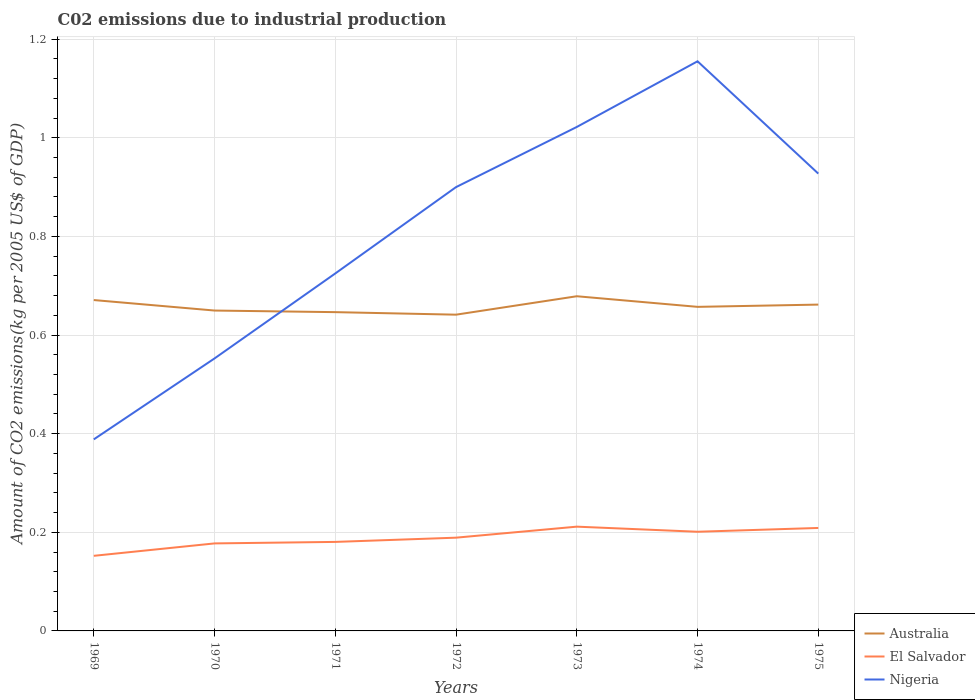Is the number of lines equal to the number of legend labels?
Your response must be concise. Yes. Across all years, what is the maximum amount of CO2 emitted due to industrial production in Australia?
Keep it short and to the point. 0.64. In which year was the amount of CO2 emitted due to industrial production in Nigeria maximum?
Provide a short and direct response. 1969. What is the total amount of CO2 emitted due to industrial production in Australia in the graph?
Provide a succinct answer. -0.01. What is the difference between the highest and the second highest amount of CO2 emitted due to industrial production in Australia?
Offer a terse response. 0.04. How many lines are there?
Keep it short and to the point. 3. How many years are there in the graph?
Provide a succinct answer. 7. What is the difference between two consecutive major ticks on the Y-axis?
Make the answer very short. 0.2. Are the values on the major ticks of Y-axis written in scientific E-notation?
Ensure brevity in your answer.  No. Does the graph contain any zero values?
Give a very brief answer. No. Where does the legend appear in the graph?
Make the answer very short. Bottom right. How many legend labels are there?
Your response must be concise. 3. What is the title of the graph?
Offer a terse response. C02 emissions due to industrial production. What is the label or title of the X-axis?
Keep it short and to the point. Years. What is the label or title of the Y-axis?
Your answer should be compact. Amount of CO2 emissions(kg per 2005 US$ of GDP). What is the Amount of CO2 emissions(kg per 2005 US$ of GDP) of Australia in 1969?
Make the answer very short. 0.67. What is the Amount of CO2 emissions(kg per 2005 US$ of GDP) of El Salvador in 1969?
Keep it short and to the point. 0.15. What is the Amount of CO2 emissions(kg per 2005 US$ of GDP) of Nigeria in 1969?
Provide a succinct answer. 0.39. What is the Amount of CO2 emissions(kg per 2005 US$ of GDP) in Australia in 1970?
Provide a short and direct response. 0.65. What is the Amount of CO2 emissions(kg per 2005 US$ of GDP) of El Salvador in 1970?
Provide a short and direct response. 0.18. What is the Amount of CO2 emissions(kg per 2005 US$ of GDP) of Nigeria in 1970?
Offer a very short reply. 0.55. What is the Amount of CO2 emissions(kg per 2005 US$ of GDP) of Australia in 1971?
Provide a short and direct response. 0.65. What is the Amount of CO2 emissions(kg per 2005 US$ of GDP) of El Salvador in 1971?
Provide a succinct answer. 0.18. What is the Amount of CO2 emissions(kg per 2005 US$ of GDP) in Nigeria in 1971?
Provide a succinct answer. 0.72. What is the Amount of CO2 emissions(kg per 2005 US$ of GDP) in Australia in 1972?
Your answer should be compact. 0.64. What is the Amount of CO2 emissions(kg per 2005 US$ of GDP) in El Salvador in 1972?
Your answer should be very brief. 0.19. What is the Amount of CO2 emissions(kg per 2005 US$ of GDP) of Nigeria in 1972?
Keep it short and to the point. 0.9. What is the Amount of CO2 emissions(kg per 2005 US$ of GDP) of Australia in 1973?
Your response must be concise. 0.68. What is the Amount of CO2 emissions(kg per 2005 US$ of GDP) of El Salvador in 1973?
Your answer should be very brief. 0.21. What is the Amount of CO2 emissions(kg per 2005 US$ of GDP) in Nigeria in 1973?
Make the answer very short. 1.02. What is the Amount of CO2 emissions(kg per 2005 US$ of GDP) in Australia in 1974?
Keep it short and to the point. 0.66. What is the Amount of CO2 emissions(kg per 2005 US$ of GDP) in El Salvador in 1974?
Your answer should be very brief. 0.2. What is the Amount of CO2 emissions(kg per 2005 US$ of GDP) of Nigeria in 1974?
Provide a succinct answer. 1.16. What is the Amount of CO2 emissions(kg per 2005 US$ of GDP) in Australia in 1975?
Make the answer very short. 0.66. What is the Amount of CO2 emissions(kg per 2005 US$ of GDP) in El Salvador in 1975?
Give a very brief answer. 0.21. What is the Amount of CO2 emissions(kg per 2005 US$ of GDP) of Nigeria in 1975?
Your answer should be very brief. 0.93. Across all years, what is the maximum Amount of CO2 emissions(kg per 2005 US$ of GDP) in Australia?
Offer a terse response. 0.68. Across all years, what is the maximum Amount of CO2 emissions(kg per 2005 US$ of GDP) of El Salvador?
Your response must be concise. 0.21. Across all years, what is the maximum Amount of CO2 emissions(kg per 2005 US$ of GDP) in Nigeria?
Your answer should be compact. 1.16. Across all years, what is the minimum Amount of CO2 emissions(kg per 2005 US$ of GDP) in Australia?
Your answer should be very brief. 0.64. Across all years, what is the minimum Amount of CO2 emissions(kg per 2005 US$ of GDP) of El Salvador?
Make the answer very short. 0.15. Across all years, what is the minimum Amount of CO2 emissions(kg per 2005 US$ of GDP) in Nigeria?
Keep it short and to the point. 0.39. What is the total Amount of CO2 emissions(kg per 2005 US$ of GDP) of Australia in the graph?
Make the answer very short. 4.61. What is the total Amount of CO2 emissions(kg per 2005 US$ of GDP) in El Salvador in the graph?
Keep it short and to the point. 1.32. What is the total Amount of CO2 emissions(kg per 2005 US$ of GDP) in Nigeria in the graph?
Keep it short and to the point. 5.67. What is the difference between the Amount of CO2 emissions(kg per 2005 US$ of GDP) in Australia in 1969 and that in 1970?
Provide a short and direct response. 0.02. What is the difference between the Amount of CO2 emissions(kg per 2005 US$ of GDP) in El Salvador in 1969 and that in 1970?
Make the answer very short. -0.03. What is the difference between the Amount of CO2 emissions(kg per 2005 US$ of GDP) of Nigeria in 1969 and that in 1970?
Provide a succinct answer. -0.16. What is the difference between the Amount of CO2 emissions(kg per 2005 US$ of GDP) of Australia in 1969 and that in 1971?
Ensure brevity in your answer.  0.02. What is the difference between the Amount of CO2 emissions(kg per 2005 US$ of GDP) in El Salvador in 1969 and that in 1971?
Ensure brevity in your answer.  -0.03. What is the difference between the Amount of CO2 emissions(kg per 2005 US$ of GDP) in Nigeria in 1969 and that in 1971?
Offer a very short reply. -0.34. What is the difference between the Amount of CO2 emissions(kg per 2005 US$ of GDP) in Australia in 1969 and that in 1972?
Make the answer very short. 0.03. What is the difference between the Amount of CO2 emissions(kg per 2005 US$ of GDP) of El Salvador in 1969 and that in 1972?
Your answer should be very brief. -0.04. What is the difference between the Amount of CO2 emissions(kg per 2005 US$ of GDP) of Nigeria in 1969 and that in 1972?
Ensure brevity in your answer.  -0.51. What is the difference between the Amount of CO2 emissions(kg per 2005 US$ of GDP) in Australia in 1969 and that in 1973?
Offer a very short reply. -0.01. What is the difference between the Amount of CO2 emissions(kg per 2005 US$ of GDP) in El Salvador in 1969 and that in 1973?
Offer a terse response. -0.06. What is the difference between the Amount of CO2 emissions(kg per 2005 US$ of GDP) in Nigeria in 1969 and that in 1973?
Keep it short and to the point. -0.63. What is the difference between the Amount of CO2 emissions(kg per 2005 US$ of GDP) of Australia in 1969 and that in 1974?
Your answer should be compact. 0.01. What is the difference between the Amount of CO2 emissions(kg per 2005 US$ of GDP) of El Salvador in 1969 and that in 1974?
Provide a succinct answer. -0.05. What is the difference between the Amount of CO2 emissions(kg per 2005 US$ of GDP) of Nigeria in 1969 and that in 1974?
Your answer should be very brief. -0.77. What is the difference between the Amount of CO2 emissions(kg per 2005 US$ of GDP) of Australia in 1969 and that in 1975?
Offer a very short reply. 0.01. What is the difference between the Amount of CO2 emissions(kg per 2005 US$ of GDP) of El Salvador in 1969 and that in 1975?
Offer a very short reply. -0.06. What is the difference between the Amount of CO2 emissions(kg per 2005 US$ of GDP) of Nigeria in 1969 and that in 1975?
Keep it short and to the point. -0.54. What is the difference between the Amount of CO2 emissions(kg per 2005 US$ of GDP) of Australia in 1970 and that in 1971?
Your answer should be very brief. 0. What is the difference between the Amount of CO2 emissions(kg per 2005 US$ of GDP) in El Salvador in 1970 and that in 1971?
Give a very brief answer. -0. What is the difference between the Amount of CO2 emissions(kg per 2005 US$ of GDP) in Nigeria in 1970 and that in 1971?
Ensure brevity in your answer.  -0.17. What is the difference between the Amount of CO2 emissions(kg per 2005 US$ of GDP) in Australia in 1970 and that in 1972?
Provide a short and direct response. 0.01. What is the difference between the Amount of CO2 emissions(kg per 2005 US$ of GDP) in El Salvador in 1970 and that in 1972?
Offer a terse response. -0.01. What is the difference between the Amount of CO2 emissions(kg per 2005 US$ of GDP) of Nigeria in 1970 and that in 1972?
Make the answer very short. -0.35. What is the difference between the Amount of CO2 emissions(kg per 2005 US$ of GDP) in Australia in 1970 and that in 1973?
Provide a succinct answer. -0.03. What is the difference between the Amount of CO2 emissions(kg per 2005 US$ of GDP) of El Salvador in 1970 and that in 1973?
Offer a very short reply. -0.03. What is the difference between the Amount of CO2 emissions(kg per 2005 US$ of GDP) of Nigeria in 1970 and that in 1973?
Offer a terse response. -0.47. What is the difference between the Amount of CO2 emissions(kg per 2005 US$ of GDP) in Australia in 1970 and that in 1974?
Your response must be concise. -0.01. What is the difference between the Amount of CO2 emissions(kg per 2005 US$ of GDP) of El Salvador in 1970 and that in 1974?
Your answer should be compact. -0.02. What is the difference between the Amount of CO2 emissions(kg per 2005 US$ of GDP) in Nigeria in 1970 and that in 1974?
Offer a very short reply. -0.6. What is the difference between the Amount of CO2 emissions(kg per 2005 US$ of GDP) of Australia in 1970 and that in 1975?
Ensure brevity in your answer.  -0.01. What is the difference between the Amount of CO2 emissions(kg per 2005 US$ of GDP) in El Salvador in 1970 and that in 1975?
Your response must be concise. -0.03. What is the difference between the Amount of CO2 emissions(kg per 2005 US$ of GDP) of Nigeria in 1970 and that in 1975?
Ensure brevity in your answer.  -0.37. What is the difference between the Amount of CO2 emissions(kg per 2005 US$ of GDP) in Australia in 1971 and that in 1972?
Your answer should be very brief. 0.01. What is the difference between the Amount of CO2 emissions(kg per 2005 US$ of GDP) in El Salvador in 1971 and that in 1972?
Make the answer very short. -0.01. What is the difference between the Amount of CO2 emissions(kg per 2005 US$ of GDP) of Nigeria in 1971 and that in 1972?
Offer a terse response. -0.18. What is the difference between the Amount of CO2 emissions(kg per 2005 US$ of GDP) in Australia in 1971 and that in 1973?
Offer a very short reply. -0.03. What is the difference between the Amount of CO2 emissions(kg per 2005 US$ of GDP) in El Salvador in 1971 and that in 1973?
Make the answer very short. -0.03. What is the difference between the Amount of CO2 emissions(kg per 2005 US$ of GDP) of Nigeria in 1971 and that in 1973?
Offer a very short reply. -0.3. What is the difference between the Amount of CO2 emissions(kg per 2005 US$ of GDP) in Australia in 1971 and that in 1974?
Offer a very short reply. -0.01. What is the difference between the Amount of CO2 emissions(kg per 2005 US$ of GDP) of El Salvador in 1971 and that in 1974?
Ensure brevity in your answer.  -0.02. What is the difference between the Amount of CO2 emissions(kg per 2005 US$ of GDP) in Nigeria in 1971 and that in 1974?
Provide a succinct answer. -0.43. What is the difference between the Amount of CO2 emissions(kg per 2005 US$ of GDP) in Australia in 1971 and that in 1975?
Provide a succinct answer. -0.02. What is the difference between the Amount of CO2 emissions(kg per 2005 US$ of GDP) of El Salvador in 1971 and that in 1975?
Your response must be concise. -0.03. What is the difference between the Amount of CO2 emissions(kg per 2005 US$ of GDP) in Nigeria in 1971 and that in 1975?
Offer a very short reply. -0.2. What is the difference between the Amount of CO2 emissions(kg per 2005 US$ of GDP) of Australia in 1972 and that in 1973?
Provide a succinct answer. -0.04. What is the difference between the Amount of CO2 emissions(kg per 2005 US$ of GDP) of El Salvador in 1972 and that in 1973?
Give a very brief answer. -0.02. What is the difference between the Amount of CO2 emissions(kg per 2005 US$ of GDP) in Nigeria in 1972 and that in 1973?
Offer a terse response. -0.12. What is the difference between the Amount of CO2 emissions(kg per 2005 US$ of GDP) in Australia in 1972 and that in 1974?
Your answer should be compact. -0.02. What is the difference between the Amount of CO2 emissions(kg per 2005 US$ of GDP) in El Salvador in 1972 and that in 1974?
Give a very brief answer. -0.01. What is the difference between the Amount of CO2 emissions(kg per 2005 US$ of GDP) in Nigeria in 1972 and that in 1974?
Your answer should be compact. -0.26. What is the difference between the Amount of CO2 emissions(kg per 2005 US$ of GDP) of Australia in 1972 and that in 1975?
Your answer should be very brief. -0.02. What is the difference between the Amount of CO2 emissions(kg per 2005 US$ of GDP) of El Salvador in 1972 and that in 1975?
Offer a terse response. -0.02. What is the difference between the Amount of CO2 emissions(kg per 2005 US$ of GDP) in Nigeria in 1972 and that in 1975?
Provide a succinct answer. -0.03. What is the difference between the Amount of CO2 emissions(kg per 2005 US$ of GDP) in Australia in 1973 and that in 1974?
Keep it short and to the point. 0.02. What is the difference between the Amount of CO2 emissions(kg per 2005 US$ of GDP) in El Salvador in 1973 and that in 1974?
Offer a very short reply. 0.01. What is the difference between the Amount of CO2 emissions(kg per 2005 US$ of GDP) of Nigeria in 1973 and that in 1974?
Offer a very short reply. -0.13. What is the difference between the Amount of CO2 emissions(kg per 2005 US$ of GDP) in Australia in 1973 and that in 1975?
Provide a succinct answer. 0.02. What is the difference between the Amount of CO2 emissions(kg per 2005 US$ of GDP) in El Salvador in 1973 and that in 1975?
Provide a short and direct response. 0. What is the difference between the Amount of CO2 emissions(kg per 2005 US$ of GDP) in Nigeria in 1973 and that in 1975?
Your answer should be compact. 0.09. What is the difference between the Amount of CO2 emissions(kg per 2005 US$ of GDP) in Australia in 1974 and that in 1975?
Your answer should be very brief. -0. What is the difference between the Amount of CO2 emissions(kg per 2005 US$ of GDP) in El Salvador in 1974 and that in 1975?
Give a very brief answer. -0.01. What is the difference between the Amount of CO2 emissions(kg per 2005 US$ of GDP) in Nigeria in 1974 and that in 1975?
Offer a terse response. 0.23. What is the difference between the Amount of CO2 emissions(kg per 2005 US$ of GDP) of Australia in 1969 and the Amount of CO2 emissions(kg per 2005 US$ of GDP) of El Salvador in 1970?
Give a very brief answer. 0.49. What is the difference between the Amount of CO2 emissions(kg per 2005 US$ of GDP) of Australia in 1969 and the Amount of CO2 emissions(kg per 2005 US$ of GDP) of Nigeria in 1970?
Offer a terse response. 0.12. What is the difference between the Amount of CO2 emissions(kg per 2005 US$ of GDP) in El Salvador in 1969 and the Amount of CO2 emissions(kg per 2005 US$ of GDP) in Nigeria in 1970?
Give a very brief answer. -0.4. What is the difference between the Amount of CO2 emissions(kg per 2005 US$ of GDP) of Australia in 1969 and the Amount of CO2 emissions(kg per 2005 US$ of GDP) of El Salvador in 1971?
Keep it short and to the point. 0.49. What is the difference between the Amount of CO2 emissions(kg per 2005 US$ of GDP) in Australia in 1969 and the Amount of CO2 emissions(kg per 2005 US$ of GDP) in Nigeria in 1971?
Your answer should be very brief. -0.05. What is the difference between the Amount of CO2 emissions(kg per 2005 US$ of GDP) of El Salvador in 1969 and the Amount of CO2 emissions(kg per 2005 US$ of GDP) of Nigeria in 1971?
Give a very brief answer. -0.57. What is the difference between the Amount of CO2 emissions(kg per 2005 US$ of GDP) in Australia in 1969 and the Amount of CO2 emissions(kg per 2005 US$ of GDP) in El Salvador in 1972?
Provide a succinct answer. 0.48. What is the difference between the Amount of CO2 emissions(kg per 2005 US$ of GDP) in Australia in 1969 and the Amount of CO2 emissions(kg per 2005 US$ of GDP) in Nigeria in 1972?
Your response must be concise. -0.23. What is the difference between the Amount of CO2 emissions(kg per 2005 US$ of GDP) of El Salvador in 1969 and the Amount of CO2 emissions(kg per 2005 US$ of GDP) of Nigeria in 1972?
Offer a terse response. -0.75. What is the difference between the Amount of CO2 emissions(kg per 2005 US$ of GDP) of Australia in 1969 and the Amount of CO2 emissions(kg per 2005 US$ of GDP) of El Salvador in 1973?
Offer a terse response. 0.46. What is the difference between the Amount of CO2 emissions(kg per 2005 US$ of GDP) in Australia in 1969 and the Amount of CO2 emissions(kg per 2005 US$ of GDP) in Nigeria in 1973?
Your answer should be very brief. -0.35. What is the difference between the Amount of CO2 emissions(kg per 2005 US$ of GDP) in El Salvador in 1969 and the Amount of CO2 emissions(kg per 2005 US$ of GDP) in Nigeria in 1973?
Ensure brevity in your answer.  -0.87. What is the difference between the Amount of CO2 emissions(kg per 2005 US$ of GDP) of Australia in 1969 and the Amount of CO2 emissions(kg per 2005 US$ of GDP) of El Salvador in 1974?
Offer a very short reply. 0.47. What is the difference between the Amount of CO2 emissions(kg per 2005 US$ of GDP) of Australia in 1969 and the Amount of CO2 emissions(kg per 2005 US$ of GDP) of Nigeria in 1974?
Your answer should be very brief. -0.48. What is the difference between the Amount of CO2 emissions(kg per 2005 US$ of GDP) of El Salvador in 1969 and the Amount of CO2 emissions(kg per 2005 US$ of GDP) of Nigeria in 1974?
Provide a short and direct response. -1. What is the difference between the Amount of CO2 emissions(kg per 2005 US$ of GDP) in Australia in 1969 and the Amount of CO2 emissions(kg per 2005 US$ of GDP) in El Salvador in 1975?
Keep it short and to the point. 0.46. What is the difference between the Amount of CO2 emissions(kg per 2005 US$ of GDP) of Australia in 1969 and the Amount of CO2 emissions(kg per 2005 US$ of GDP) of Nigeria in 1975?
Provide a short and direct response. -0.26. What is the difference between the Amount of CO2 emissions(kg per 2005 US$ of GDP) in El Salvador in 1969 and the Amount of CO2 emissions(kg per 2005 US$ of GDP) in Nigeria in 1975?
Provide a short and direct response. -0.78. What is the difference between the Amount of CO2 emissions(kg per 2005 US$ of GDP) in Australia in 1970 and the Amount of CO2 emissions(kg per 2005 US$ of GDP) in El Salvador in 1971?
Your answer should be very brief. 0.47. What is the difference between the Amount of CO2 emissions(kg per 2005 US$ of GDP) in Australia in 1970 and the Amount of CO2 emissions(kg per 2005 US$ of GDP) in Nigeria in 1971?
Your response must be concise. -0.08. What is the difference between the Amount of CO2 emissions(kg per 2005 US$ of GDP) of El Salvador in 1970 and the Amount of CO2 emissions(kg per 2005 US$ of GDP) of Nigeria in 1971?
Provide a succinct answer. -0.55. What is the difference between the Amount of CO2 emissions(kg per 2005 US$ of GDP) of Australia in 1970 and the Amount of CO2 emissions(kg per 2005 US$ of GDP) of El Salvador in 1972?
Your response must be concise. 0.46. What is the difference between the Amount of CO2 emissions(kg per 2005 US$ of GDP) of Australia in 1970 and the Amount of CO2 emissions(kg per 2005 US$ of GDP) of Nigeria in 1972?
Make the answer very short. -0.25. What is the difference between the Amount of CO2 emissions(kg per 2005 US$ of GDP) in El Salvador in 1970 and the Amount of CO2 emissions(kg per 2005 US$ of GDP) in Nigeria in 1972?
Make the answer very short. -0.72. What is the difference between the Amount of CO2 emissions(kg per 2005 US$ of GDP) of Australia in 1970 and the Amount of CO2 emissions(kg per 2005 US$ of GDP) of El Salvador in 1973?
Provide a short and direct response. 0.44. What is the difference between the Amount of CO2 emissions(kg per 2005 US$ of GDP) of Australia in 1970 and the Amount of CO2 emissions(kg per 2005 US$ of GDP) of Nigeria in 1973?
Your response must be concise. -0.37. What is the difference between the Amount of CO2 emissions(kg per 2005 US$ of GDP) of El Salvador in 1970 and the Amount of CO2 emissions(kg per 2005 US$ of GDP) of Nigeria in 1973?
Ensure brevity in your answer.  -0.84. What is the difference between the Amount of CO2 emissions(kg per 2005 US$ of GDP) of Australia in 1970 and the Amount of CO2 emissions(kg per 2005 US$ of GDP) of El Salvador in 1974?
Keep it short and to the point. 0.45. What is the difference between the Amount of CO2 emissions(kg per 2005 US$ of GDP) in Australia in 1970 and the Amount of CO2 emissions(kg per 2005 US$ of GDP) in Nigeria in 1974?
Give a very brief answer. -0.51. What is the difference between the Amount of CO2 emissions(kg per 2005 US$ of GDP) of El Salvador in 1970 and the Amount of CO2 emissions(kg per 2005 US$ of GDP) of Nigeria in 1974?
Offer a terse response. -0.98. What is the difference between the Amount of CO2 emissions(kg per 2005 US$ of GDP) of Australia in 1970 and the Amount of CO2 emissions(kg per 2005 US$ of GDP) of El Salvador in 1975?
Provide a short and direct response. 0.44. What is the difference between the Amount of CO2 emissions(kg per 2005 US$ of GDP) in Australia in 1970 and the Amount of CO2 emissions(kg per 2005 US$ of GDP) in Nigeria in 1975?
Give a very brief answer. -0.28. What is the difference between the Amount of CO2 emissions(kg per 2005 US$ of GDP) of El Salvador in 1970 and the Amount of CO2 emissions(kg per 2005 US$ of GDP) of Nigeria in 1975?
Your answer should be compact. -0.75. What is the difference between the Amount of CO2 emissions(kg per 2005 US$ of GDP) in Australia in 1971 and the Amount of CO2 emissions(kg per 2005 US$ of GDP) in El Salvador in 1972?
Offer a very short reply. 0.46. What is the difference between the Amount of CO2 emissions(kg per 2005 US$ of GDP) in Australia in 1971 and the Amount of CO2 emissions(kg per 2005 US$ of GDP) in Nigeria in 1972?
Provide a succinct answer. -0.25. What is the difference between the Amount of CO2 emissions(kg per 2005 US$ of GDP) of El Salvador in 1971 and the Amount of CO2 emissions(kg per 2005 US$ of GDP) of Nigeria in 1972?
Offer a terse response. -0.72. What is the difference between the Amount of CO2 emissions(kg per 2005 US$ of GDP) in Australia in 1971 and the Amount of CO2 emissions(kg per 2005 US$ of GDP) in El Salvador in 1973?
Provide a succinct answer. 0.43. What is the difference between the Amount of CO2 emissions(kg per 2005 US$ of GDP) of Australia in 1971 and the Amount of CO2 emissions(kg per 2005 US$ of GDP) of Nigeria in 1973?
Your answer should be compact. -0.38. What is the difference between the Amount of CO2 emissions(kg per 2005 US$ of GDP) in El Salvador in 1971 and the Amount of CO2 emissions(kg per 2005 US$ of GDP) in Nigeria in 1973?
Your answer should be compact. -0.84. What is the difference between the Amount of CO2 emissions(kg per 2005 US$ of GDP) in Australia in 1971 and the Amount of CO2 emissions(kg per 2005 US$ of GDP) in El Salvador in 1974?
Provide a succinct answer. 0.45. What is the difference between the Amount of CO2 emissions(kg per 2005 US$ of GDP) in Australia in 1971 and the Amount of CO2 emissions(kg per 2005 US$ of GDP) in Nigeria in 1974?
Keep it short and to the point. -0.51. What is the difference between the Amount of CO2 emissions(kg per 2005 US$ of GDP) in El Salvador in 1971 and the Amount of CO2 emissions(kg per 2005 US$ of GDP) in Nigeria in 1974?
Make the answer very short. -0.97. What is the difference between the Amount of CO2 emissions(kg per 2005 US$ of GDP) in Australia in 1971 and the Amount of CO2 emissions(kg per 2005 US$ of GDP) in El Salvador in 1975?
Keep it short and to the point. 0.44. What is the difference between the Amount of CO2 emissions(kg per 2005 US$ of GDP) in Australia in 1971 and the Amount of CO2 emissions(kg per 2005 US$ of GDP) in Nigeria in 1975?
Provide a short and direct response. -0.28. What is the difference between the Amount of CO2 emissions(kg per 2005 US$ of GDP) in El Salvador in 1971 and the Amount of CO2 emissions(kg per 2005 US$ of GDP) in Nigeria in 1975?
Ensure brevity in your answer.  -0.75. What is the difference between the Amount of CO2 emissions(kg per 2005 US$ of GDP) of Australia in 1972 and the Amount of CO2 emissions(kg per 2005 US$ of GDP) of El Salvador in 1973?
Keep it short and to the point. 0.43. What is the difference between the Amount of CO2 emissions(kg per 2005 US$ of GDP) of Australia in 1972 and the Amount of CO2 emissions(kg per 2005 US$ of GDP) of Nigeria in 1973?
Offer a very short reply. -0.38. What is the difference between the Amount of CO2 emissions(kg per 2005 US$ of GDP) of El Salvador in 1972 and the Amount of CO2 emissions(kg per 2005 US$ of GDP) of Nigeria in 1973?
Give a very brief answer. -0.83. What is the difference between the Amount of CO2 emissions(kg per 2005 US$ of GDP) in Australia in 1972 and the Amount of CO2 emissions(kg per 2005 US$ of GDP) in El Salvador in 1974?
Offer a very short reply. 0.44. What is the difference between the Amount of CO2 emissions(kg per 2005 US$ of GDP) of Australia in 1972 and the Amount of CO2 emissions(kg per 2005 US$ of GDP) of Nigeria in 1974?
Ensure brevity in your answer.  -0.51. What is the difference between the Amount of CO2 emissions(kg per 2005 US$ of GDP) of El Salvador in 1972 and the Amount of CO2 emissions(kg per 2005 US$ of GDP) of Nigeria in 1974?
Offer a terse response. -0.97. What is the difference between the Amount of CO2 emissions(kg per 2005 US$ of GDP) of Australia in 1972 and the Amount of CO2 emissions(kg per 2005 US$ of GDP) of El Salvador in 1975?
Your answer should be very brief. 0.43. What is the difference between the Amount of CO2 emissions(kg per 2005 US$ of GDP) of Australia in 1972 and the Amount of CO2 emissions(kg per 2005 US$ of GDP) of Nigeria in 1975?
Your response must be concise. -0.29. What is the difference between the Amount of CO2 emissions(kg per 2005 US$ of GDP) of El Salvador in 1972 and the Amount of CO2 emissions(kg per 2005 US$ of GDP) of Nigeria in 1975?
Give a very brief answer. -0.74. What is the difference between the Amount of CO2 emissions(kg per 2005 US$ of GDP) in Australia in 1973 and the Amount of CO2 emissions(kg per 2005 US$ of GDP) in El Salvador in 1974?
Provide a succinct answer. 0.48. What is the difference between the Amount of CO2 emissions(kg per 2005 US$ of GDP) of Australia in 1973 and the Amount of CO2 emissions(kg per 2005 US$ of GDP) of Nigeria in 1974?
Keep it short and to the point. -0.48. What is the difference between the Amount of CO2 emissions(kg per 2005 US$ of GDP) in El Salvador in 1973 and the Amount of CO2 emissions(kg per 2005 US$ of GDP) in Nigeria in 1974?
Offer a very short reply. -0.94. What is the difference between the Amount of CO2 emissions(kg per 2005 US$ of GDP) of Australia in 1973 and the Amount of CO2 emissions(kg per 2005 US$ of GDP) of El Salvador in 1975?
Make the answer very short. 0.47. What is the difference between the Amount of CO2 emissions(kg per 2005 US$ of GDP) in Australia in 1973 and the Amount of CO2 emissions(kg per 2005 US$ of GDP) in Nigeria in 1975?
Provide a succinct answer. -0.25. What is the difference between the Amount of CO2 emissions(kg per 2005 US$ of GDP) in El Salvador in 1973 and the Amount of CO2 emissions(kg per 2005 US$ of GDP) in Nigeria in 1975?
Offer a terse response. -0.72. What is the difference between the Amount of CO2 emissions(kg per 2005 US$ of GDP) in Australia in 1974 and the Amount of CO2 emissions(kg per 2005 US$ of GDP) in El Salvador in 1975?
Provide a short and direct response. 0.45. What is the difference between the Amount of CO2 emissions(kg per 2005 US$ of GDP) in Australia in 1974 and the Amount of CO2 emissions(kg per 2005 US$ of GDP) in Nigeria in 1975?
Make the answer very short. -0.27. What is the difference between the Amount of CO2 emissions(kg per 2005 US$ of GDP) of El Salvador in 1974 and the Amount of CO2 emissions(kg per 2005 US$ of GDP) of Nigeria in 1975?
Provide a short and direct response. -0.73. What is the average Amount of CO2 emissions(kg per 2005 US$ of GDP) in Australia per year?
Offer a very short reply. 0.66. What is the average Amount of CO2 emissions(kg per 2005 US$ of GDP) in El Salvador per year?
Offer a very short reply. 0.19. What is the average Amount of CO2 emissions(kg per 2005 US$ of GDP) in Nigeria per year?
Ensure brevity in your answer.  0.81. In the year 1969, what is the difference between the Amount of CO2 emissions(kg per 2005 US$ of GDP) of Australia and Amount of CO2 emissions(kg per 2005 US$ of GDP) of El Salvador?
Your answer should be compact. 0.52. In the year 1969, what is the difference between the Amount of CO2 emissions(kg per 2005 US$ of GDP) in Australia and Amount of CO2 emissions(kg per 2005 US$ of GDP) in Nigeria?
Offer a very short reply. 0.28. In the year 1969, what is the difference between the Amount of CO2 emissions(kg per 2005 US$ of GDP) in El Salvador and Amount of CO2 emissions(kg per 2005 US$ of GDP) in Nigeria?
Your response must be concise. -0.24. In the year 1970, what is the difference between the Amount of CO2 emissions(kg per 2005 US$ of GDP) in Australia and Amount of CO2 emissions(kg per 2005 US$ of GDP) in El Salvador?
Offer a terse response. 0.47. In the year 1970, what is the difference between the Amount of CO2 emissions(kg per 2005 US$ of GDP) in Australia and Amount of CO2 emissions(kg per 2005 US$ of GDP) in Nigeria?
Your answer should be very brief. 0.1. In the year 1970, what is the difference between the Amount of CO2 emissions(kg per 2005 US$ of GDP) in El Salvador and Amount of CO2 emissions(kg per 2005 US$ of GDP) in Nigeria?
Offer a very short reply. -0.38. In the year 1971, what is the difference between the Amount of CO2 emissions(kg per 2005 US$ of GDP) of Australia and Amount of CO2 emissions(kg per 2005 US$ of GDP) of El Salvador?
Your answer should be very brief. 0.47. In the year 1971, what is the difference between the Amount of CO2 emissions(kg per 2005 US$ of GDP) in Australia and Amount of CO2 emissions(kg per 2005 US$ of GDP) in Nigeria?
Ensure brevity in your answer.  -0.08. In the year 1971, what is the difference between the Amount of CO2 emissions(kg per 2005 US$ of GDP) of El Salvador and Amount of CO2 emissions(kg per 2005 US$ of GDP) of Nigeria?
Make the answer very short. -0.54. In the year 1972, what is the difference between the Amount of CO2 emissions(kg per 2005 US$ of GDP) of Australia and Amount of CO2 emissions(kg per 2005 US$ of GDP) of El Salvador?
Provide a short and direct response. 0.45. In the year 1972, what is the difference between the Amount of CO2 emissions(kg per 2005 US$ of GDP) in Australia and Amount of CO2 emissions(kg per 2005 US$ of GDP) in Nigeria?
Provide a short and direct response. -0.26. In the year 1972, what is the difference between the Amount of CO2 emissions(kg per 2005 US$ of GDP) in El Salvador and Amount of CO2 emissions(kg per 2005 US$ of GDP) in Nigeria?
Make the answer very short. -0.71. In the year 1973, what is the difference between the Amount of CO2 emissions(kg per 2005 US$ of GDP) of Australia and Amount of CO2 emissions(kg per 2005 US$ of GDP) of El Salvador?
Offer a very short reply. 0.47. In the year 1973, what is the difference between the Amount of CO2 emissions(kg per 2005 US$ of GDP) in Australia and Amount of CO2 emissions(kg per 2005 US$ of GDP) in Nigeria?
Offer a very short reply. -0.34. In the year 1973, what is the difference between the Amount of CO2 emissions(kg per 2005 US$ of GDP) in El Salvador and Amount of CO2 emissions(kg per 2005 US$ of GDP) in Nigeria?
Your answer should be very brief. -0.81. In the year 1974, what is the difference between the Amount of CO2 emissions(kg per 2005 US$ of GDP) in Australia and Amount of CO2 emissions(kg per 2005 US$ of GDP) in El Salvador?
Provide a short and direct response. 0.46. In the year 1974, what is the difference between the Amount of CO2 emissions(kg per 2005 US$ of GDP) in Australia and Amount of CO2 emissions(kg per 2005 US$ of GDP) in Nigeria?
Your answer should be very brief. -0.5. In the year 1974, what is the difference between the Amount of CO2 emissions(kg per 2005 US$ of GDP) of El Salvador and Amount of CO2 emissions(kg per 2005 US$ of GDP) of Nigeria?
Give a very brief answer. -0.95. In the year 1975, what is the difference between the Amount of CO2 emissions(kg per 2005 US$ of GDP) of Australia and Amount of CO2 emissions(kg per 2005 US$ of GDP) of El Salvador?
Provide a short and direct response. 0.45. In the year 1975, what is the difference between the Amount of CO2 emissions(kg per 2005 US$ of GDP) of Australia and Amount of CO2 emissions(kg per 2005 US$ of GDP) of Nigeria?
Ensure brevity in your answer.  -0.27. In the year 1975, what is the difference between the Amount of CO2 emissions(kg per 2005 US$ of GDP) in El Salvador and Amount of CO2 emissions(kg per 2005 US$ of GDP) in Nigeria?
Your answer should be compact. -0.72. What is the ratio of the Amount of CO2 emissions(kg per 2005 US$ of GDP) of Australia in 1969 to that in 1970?
Ensure brevity in your answer.  1.03. What is the ratio of the Amount of CO2 emissions(kg per 2005 US$ of GDP) in El Salvador in 1969 to that in 1970?
Your response must be concise. 0.86. What is the ratio of the Amount of CO2 emissions(kg per 2005 US$ of GDP) in Nigeria in 1969 to that in 1970?
Ensure brevity in your answer.  0.7. What is the ratio of the Amount of CO2 emissions(kg per 2005 US$ of GDP) of Australia in 1969 to that in 1971?
Ensure brevity in your answer.  1.04. What is the ratio of the Amount of CO2 emissions(kg per 2005 US$ of GDP) in El Salvador in 1969 to that in 1971?
Offer a terse response. 0.84. What is the ratio of the Amount of CO2 emissions(kg per 2005 US$ of GDP) in Nigeria in 1969 to that in 1971?
Provide a succinct answer. 0.54. What is the ratio of the Amount of CO2 emissions(kg per 2005 US$ of GDP) in Australia in 1969 to that in 1972?
Keep it short and to the point. 1.05. What is the ratio of the Amount of CO2 emissions(kg per 2005 US$ of GDP) in El Salvador in 1969 to that in 1972?
Provide a short and direct response. 0.81. What is the ratio of the Amount of CO2 emissions(kg per 2005 US$ of GDP) in Nigeria in 1969 to that in 1972?
Keep it short and to the point. 0.43. What is the ratio of the Amount of CO2 emissions(kg per 2005 US$ of GDP) in El Salvador in 1969 to that in 1973?
Make the answer very short. 0.72. What is the ratio of the Amount of CO2 emissions(kg per 2005 US$ of GDP) in Nigeria in 1969 to that in 1973?
Give a very brief answer. 0.38. What is the ratio of the Amount of CO2 emissions(kg per 2005 US$ of GDP) of El Salvador in 1969 to that in 1974?
Offer a very short reply. 0.76. What is the ratio of the Amount of CO2 emissions(kg per 2005 US$ of GDP) of Nigeria in 1969 to that in 1974?
Make the answer very short. 0.34. What is the ratio of the Amount of CO2 emissions(kg per 2005 US$ of GDP) in Australia in 1969 to that in 1975?
Your response must be concise. 1.01. What is the ratio of the Amount of CO2 emissions(kg per 2005 US$ of GDP) in El Salvador in 1969 to that in 1975?
Your response must be concise. 0.73. What is the ratio of the Amount of CO2 emissions(kg per 2005 US$ of GDP) in Nigeria in 1969 to that in 1975?
Provide a succinct answer. 0.42. What is the ratio of the Amount of CO2 emissions(kg per 2005 US$ of GDP) in Australia in 1970 to that in 1971?
Provide a short and direct response. 1. What is the ratio of the Amount of CO2 emissions(kg per 2005 US$ of GDP) in El Salvador in 1970 to that in 1971?
Offer a very short reply. 0.98. What is the ratio of the Amount of CO2 emissions(kg per 2005 US$ of GDP) in Nigeria in 1970 to that in 1971?
Offer a very short reply. 0.76. What is the ratio of the Amount of CO2 emissions(kg per 2005 US$ of GDP) of El Salvador in 1970 to that in 1972?
Your response must be concise. 0.94. What is the ratio of the Amount of CO2 emissions(kg per 2005 US$ of GDP) of Nigeria in 1970 to that in 1972?
Your answer should be very brief. 0.61. What is the ratio of the Amount of CO2 emissions(kg per 2005 US$ of GDP) in Australia in 1970 to that in 1973?
Provide a short and direct response. 0.96. What is the ratio of the Amount of CO2 emissions(kg per 2005 US$ of GDP) in El Salvador in 1970 to that in 1973?
Ensure brevity in your answer.  0.84. What is the ratio of the Amount of CO2 emissions(kg per 2005 US$ of GDP) in Nigeria in 1970 to that in 1973?
Keep it short and to the point. 0.54. What is the ratio of the Amount of CO2 emissions(kg per 2005 US$ of GDP) in El Salvador in 1970 to that in 1974?
Give a very brief answer. 0.88. What is the ratio of the Amount of CO2 emissions(kg per 2005 US$ of GDP) of Nigeria in 1970 to that in 1974?
Provide a succinct answer. 0.48. What is the ratio of the Amount of CO2 emissions(kg per 2005 US$ of GDP) of Australia in 1970 to that in 1975?
Give a very brief answer. 0.98. What is the ratio of the Amount of CO2 emissions(kg per 2005 US$ of GDP) in El Salvador in 1970 to that in 1975?
Make the answer very short. 0.85. What is the ratio of the Amount of CO2 emissions(kg per 2005 US$ of GDP) of Nigeria in 1970 to that in 1975?
Your response must be concise. 0.6. What is the ratio of the Amount of CO2 emissions(kg per 2005 US$ of GDP) of Australia in 1971 to that in 1972?
Your answer should be very brief. 1.01. What is the ratio of the Amount of CO2 emissions(kg per 2005 US$ of GDP) in El Salvador in 1971 to that in 1972?
Keep it short and to the point. 0.95. What is the ratio of the Amount of CO2 emissions(kg per 2005 US$ of GDP) in Nigeria in 1971 to that in 1972?
Your answer should be very brief. 0.81. What is the ratio of the Amount of CO2 emissions(kg per 2005 US$ of GDP) of Australia in 1971 to that in 1973?
Offer a very short reply. 0.95. What is the ratio of the Amount of CO2 emissions(kg per 2005 US$ of GDP) in El Salvador in 1971 to that in 1973?
Your answer should be very brief. 0.85. What is the ratio of the Amount of CO2 emissions(kg per 2005 US$ of GDP) of Nigeria in 1971 to that in 1973?
Your answer should be very brief. 0.71. What is the ratio of the Amount of CO2 emissions(kg per 2005 US$ of GDP) of Australia in 1971 to that in 1974?
Provide a short and direct response. 0.98. What is the ratio of the Amount of CO2 emissions(kg per 2005 US$ of GDP) of El Salvador in 1971 to that in 1974?
Your response must be concise. 0.9. What is the ratio of the Amount of CO2 emissions(kg per 2005 US$ of GDP) in Nigeria in 1971 to that in 1974?
Your response must be concise. 0.63. What is the ratio of the Amount of CO2 emissions(kg per 2005 US$ of GDP) in Australia in 1971 to that in 1975?
Give a very brief answer. 0.98. What is the ratio of the Amount of CO2 emissions(kg per 2005 US$ of GDP) of El Salvador in 1971 to that in 1975?
Provide a short and direct response. 0.86. What is the ratio of the Amount of CO2 emissions(kg per 2005 US$ of GDP) of Nigeria in 1971 to that in 1975?
Provide a short and direct response. 0.78. What is the ratio of the Amount of CO2 emissions(kg per 2005 US$ of GDP) in Australia in 1972 to that in 1973?
Your answer should be very brief. 0.94. What is the ratio of the Amount of CO2 emissions(kg per 2005 US$ of GDP) of El Salvador in 1972 to that in 1973?
Ensure brevity in your answer.  0.89. What is the ratio of the Amount of CO2 emissions(kg per 2005 US$ of GDP) in Nigeria in 1972 to that in 1973?
Provide a succinct answer. 0.88. What is the ratio of the Amount of CO2 emissions(kg per 2005 US$ of GDP) of Australia in 1972 to that in 1974?
Keep it short and to the point. 0.98. What is the ratio of the Amount of CO2 emissions(kg per 2005 US$ of GDP) of El Salvador in 1972 to that in 1974?
Your response must be concise. 0.94. What is the ratio of the Amount of CO2 emissions(kg per 2005 US$ of GDP) of Nigeria in 1972 to that in 1974?
Make the answer very short. 0.78. What is the ratio of the Amount of CO2 emissions(kg per 2005 US$ of GDP) of Australia in 1972 to that in 1975?
Offer a terse response. 0.97. What is the ratio of the Amount of CO2 emissions(kg per 2005 US$ of GDP) in El Salvador in 1972 to that in 1975?
Provide a short and direct response. 0.91. What is the ratio of the Amount of CO2 emissions(kg per 2005 US$ of GDP) of Nigeria in 1972 to that in 1975?
Provide a succinct answer. 0.97. What is the ratio of the Amount of CO2 emissions(kg per 2005 US$ of GDP) in Australia in 1973 to that in 1974?
Provide a succinct answer. 1.03. What is the ratio of the Amount of CO2 emissions(kg per 2005 US$ of GDP) in El Salvador in 1973 to that in 1974?
Provide a short and direct response. 1.05. What is the ratio of the Amount of CO2 emissions(kg per 2005 US$ of GDP) of Nigeria in 1973 to that in 1974?
Keep it short and to the point. 0.88. What is the ratio of the Amount of CO2 emissions(kg per 2005 US$ of GDP) of Australia in 1973 to that in 1975?
Offer a very short reply. 1.03. What is the ratio of the Amount of CO2 emissions(kg per 2005 US$ of GDP) of El Salvador in 1973 to that in 1975?
Offer a terse response. 1.01. What is the ratio of the Amount of CO2 emissions(kg per 2005 US$ of GDP) in Nigeria in 1973 to that in 1975?
Offer a terse response. 1.1. What is the ratio of the Amount of CO2 emissions(kg per 2005 US$ of GDP) in Australia in 1974 to that in 1975?
Provide a short and direct response. 0.99. What is the ratio of the Amount of CO2 emissions(kg per 2005 US$ of GDP) of El Salvador in 1974 to that in 1975?
Your response must be concise. 0.96. What is the ratio of the Amount of CO2 emissions(kg per 2005 US$ of GDP) in Nigeria in 1974 to that in 1975?
Provide a short and direct response. 1.25. What is the difference between the highest and the second highest Amount of CO2 emissions(kg per 2005 US$ of GDP) in Australia?
Ensure brevity in your answer.  0.01. What is the difference between the highest and the second highest Amount of CO2 emissions(kg per 2005 US$ of GDP) in El Salvador?
Make the answer very short. 0. What is the difference between the highest and the second highest Amount of CO2 emissions(kg per 2005 US$ of GDP) of Nigeria?
Provide a short and direct response. 0.13. What is the difference between the highest and the lowest Amount of CO2 emissions(kg per 2005 US$ of GDP) of Australia?
Keep it short and to the point. 0.04. What is the difference between the highest and the lowest Amount of CO2 emissions(kg per 2005 US$ of GDP) in El Salvador?
Your response must be concise. 0.06. What is the difference between the highest and the lowest Amount of CO2 emissions(kg per 2005 US$ of GDP) of Nigeria?
Provide a short and direct response. 0.77. 